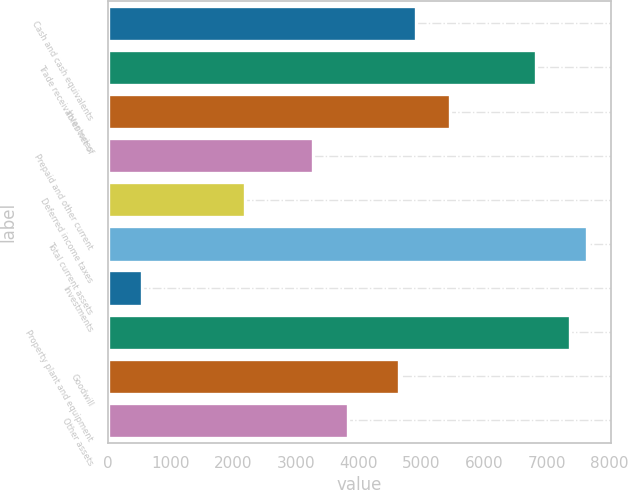Convert chart to OTSL. <chart><loc_0><loc_0><loc_500><loc_500><bar_chart><fcel>Cash and cash equivalents<fcel>Trade receivables net of<fcel>Inventories<fcel>Prepaid and other current<fcel>Deferred income taxes<fcel>Total current assets<fcel>Investments<fcel>Property plant and equipment<fcel>Goodwill<fcel>Other assets<nl><fcel>4919.32<fcel>6830.6<fcel>5465.4<fcel>3281.08<fcel>2188.92<fcel>7649.72<fcel>550.68<fcel>7376.68<fcel>4646.28<fcel>3827.16<nl></chart> 